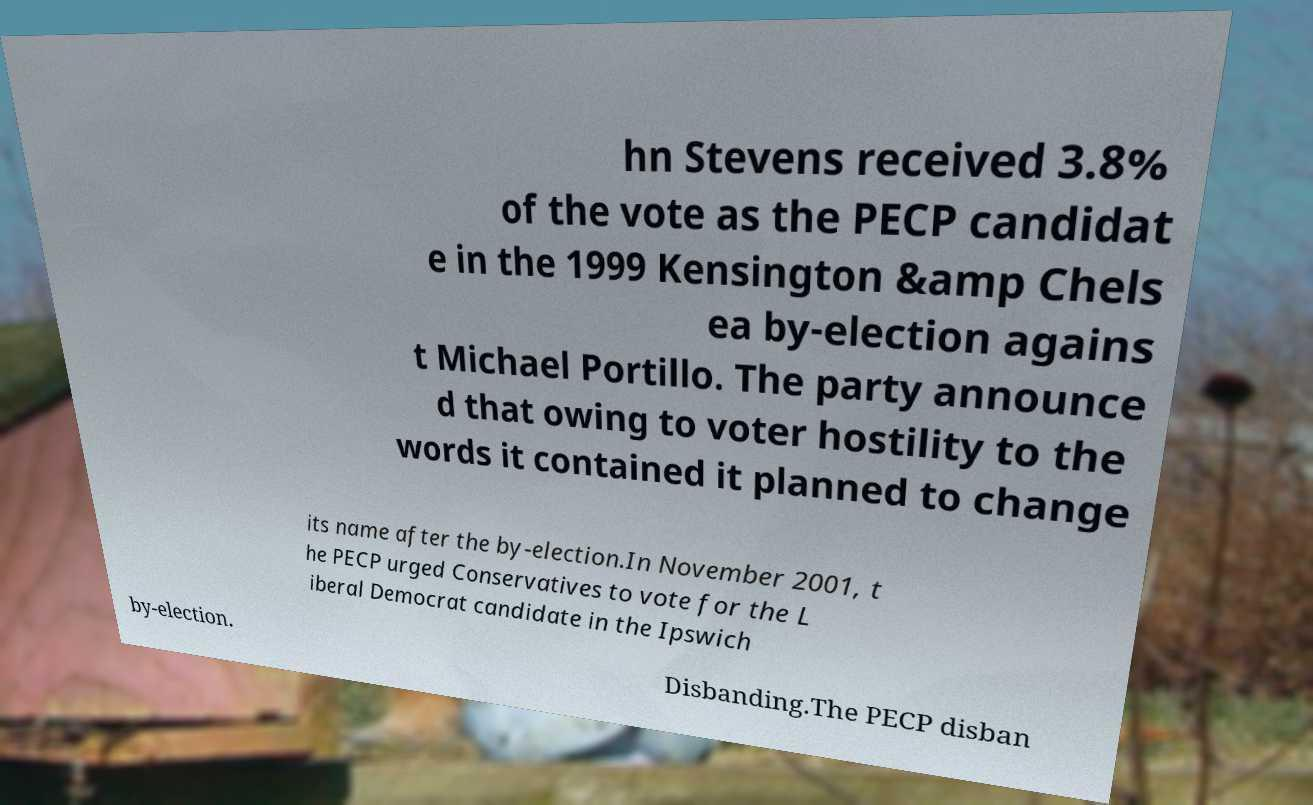Could you extract and type out the text from this image? hn Stevens received 3.8% of the vote as the PECP candidat e in the 1999 Kensington &amp Chels ea by-election agains t Michael Portillo. The party announce d that owing to voter hostility to the words it contained it planned to change its name after the by-election.In November 2001, t he PECP urged Conservatives to vote for the L iberal Democrat candidate in the Ipswich by-election. Disbanding.The PECP disban 